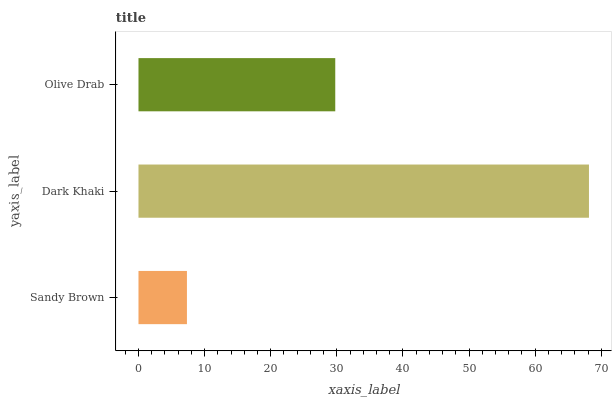Is Sandy Brown the minimum?
Answer yes or no. Yes. Is Dark Khaki the maximum?
Answer yes or no. Yes. Is Olive Drab the minimum?
Answer yes or no. No. Is Olive Drab the maximum?
Answer yes or no. No. Is Dark Khaki greater than Olive Drab?
Answer yes or no. Yes. Is Olive Drab less than Dark Khaki?
Answer yes or no. Yes. Is Olive Drab greater than Dark Khaki?
Answer yes or no. No. Is Dark Khaki less than Olive Drab?
Answer yes or no. No. Is Olive Drab the high median?
Answer yes or no. Yes. Is Olive Drab the low median?
Answer yes or no. Yes. Is Dark Khaki the high median?
Answer yes or no. No. Is Sandy Brown the low median?
Answer yes or no. No. 